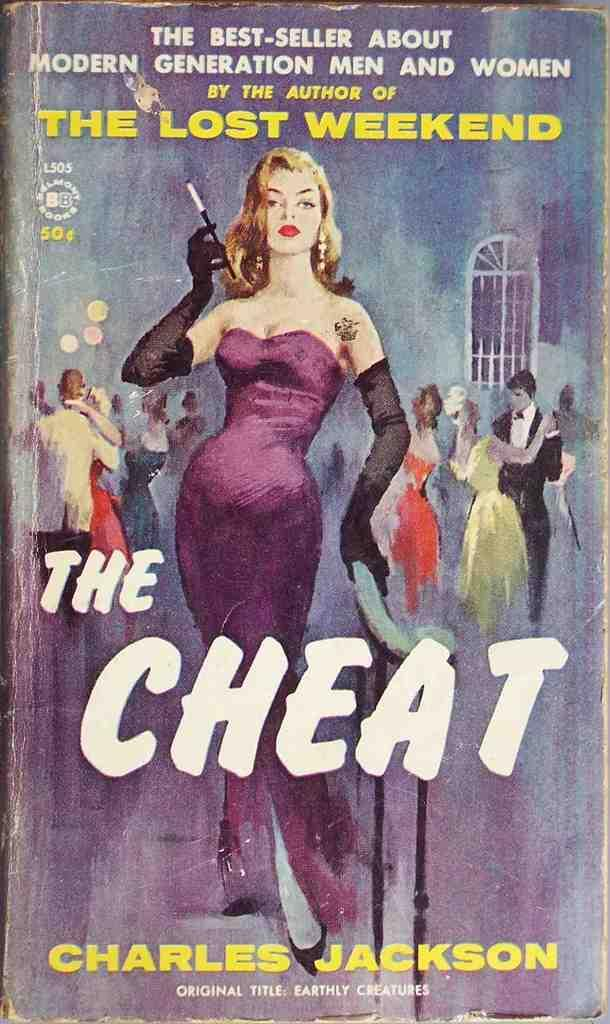What is the main subject of the image? The main subject of the image is the cover page of a book. What can be seen on the cover page? There is text and people's images on the cover page. Can you tell me how many tins are visible on the cover page? There are no tins present on the cover page; it features text and people's images. Is there a river flowing through the images of people on the cover page? There is no river present in the image; it only features text and people's images on the cover page of a book. 